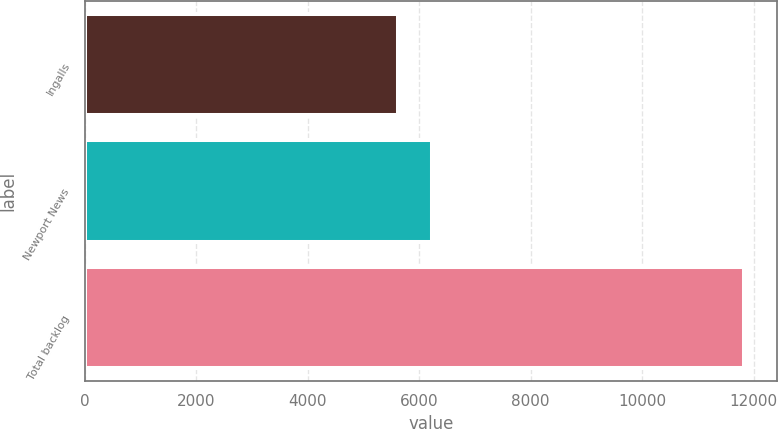<chart> <loc_0><loc_0><loc_500><loc_500><bar_chart><fcel>Ingalls<fcel>Newport News<fcel>Total backlog<nl><fcel>5609<fcel>6231.3<fcel>11832<nl></chart> 